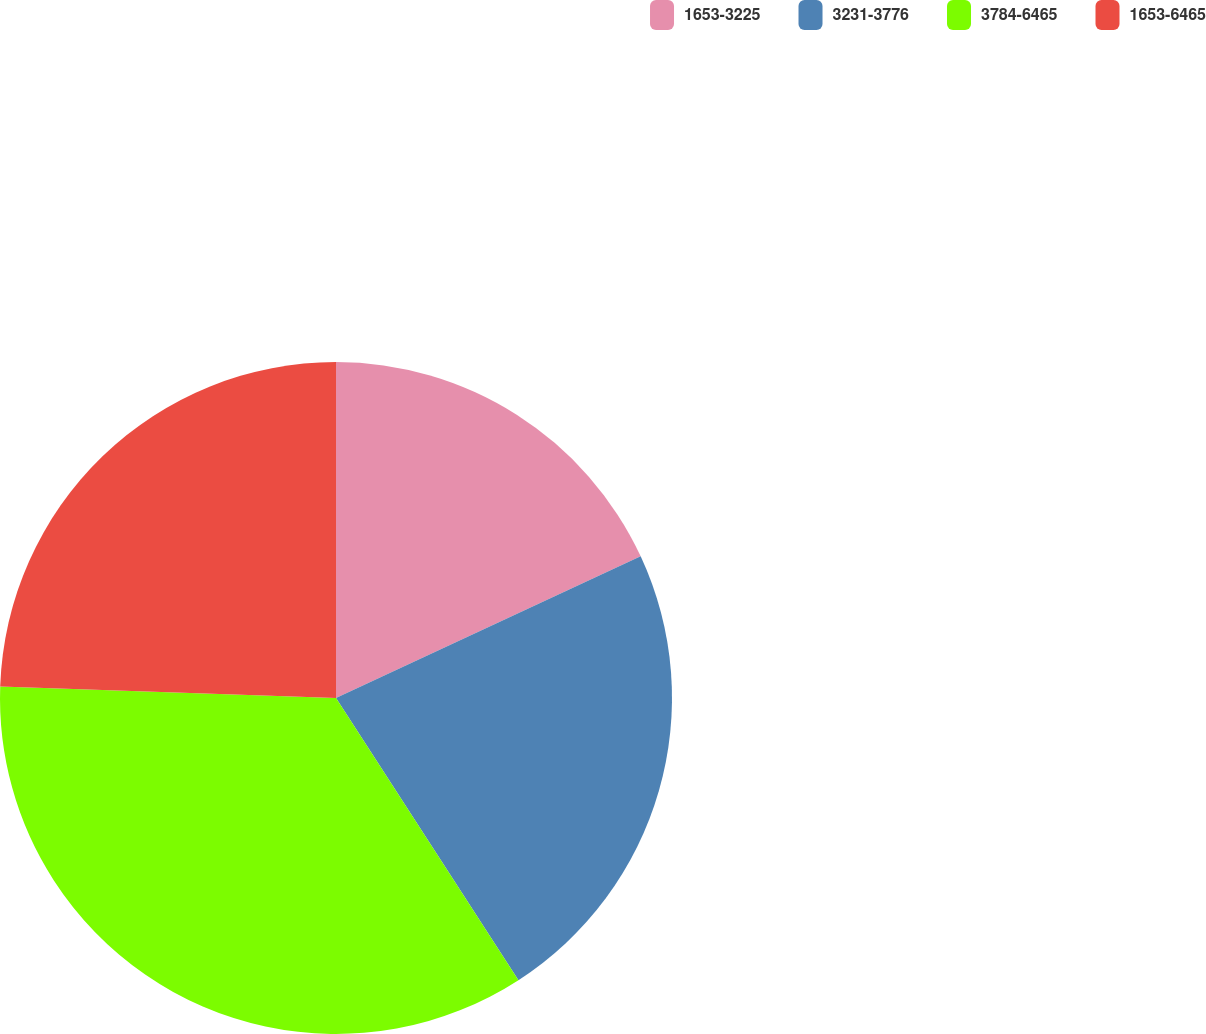Convert chart. <chart><loc_0><loc_0><loc_500><loc_500><pie_chart><fcel>1653-3225<fcel>3231-3776<fcel>3784-6465<fcel>1653-6465<nl><fcel>18.07%<fcel>22.79%<fcel>34.68%<fcel>24.45%<nl></chart> 